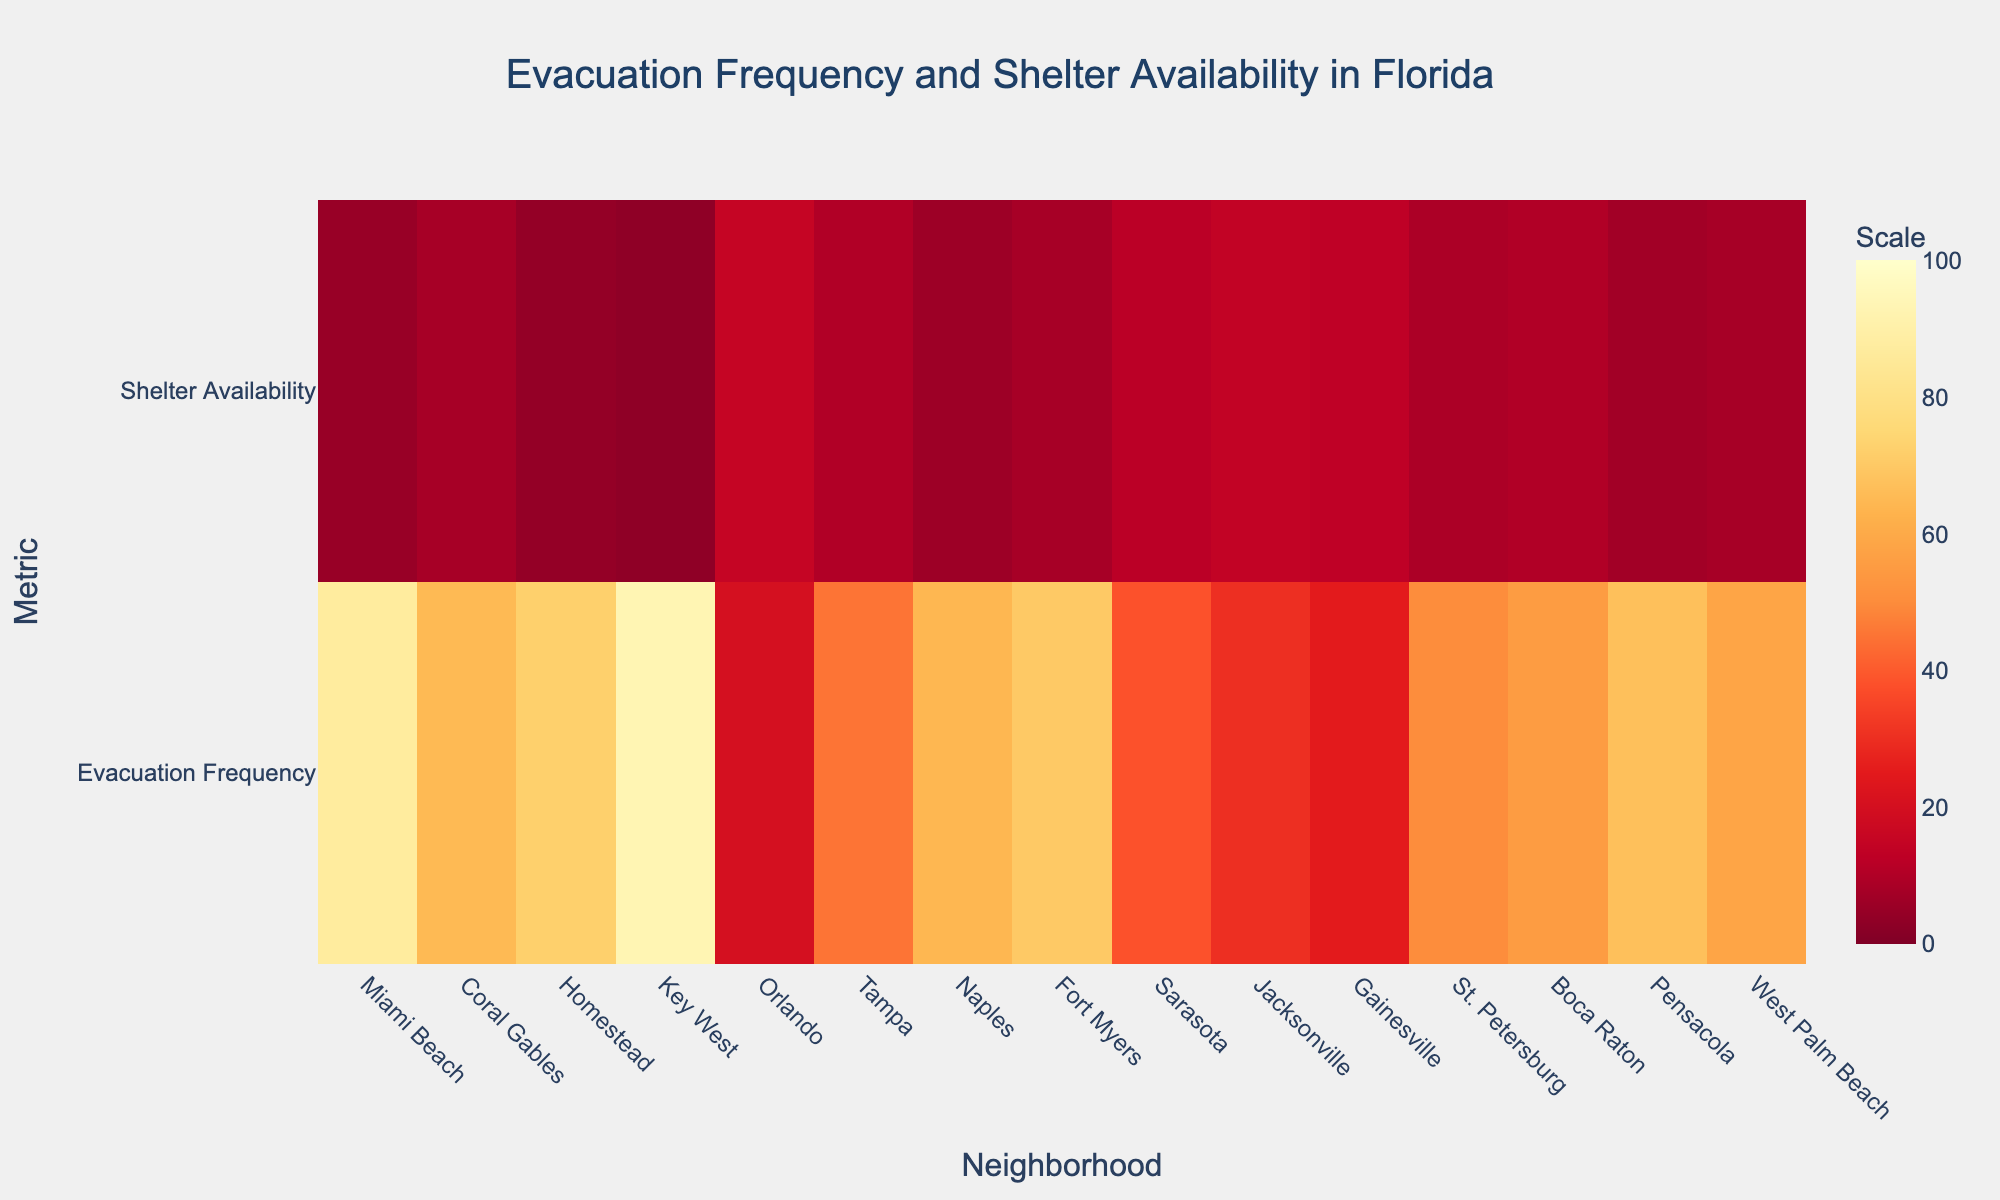What is the title of the heatmap? The title is prominently displayed at the top of the heatmap. It says, "Evacuation Frequency and Shelter Availability in Florida".
Answer: Evacuation Frequency and Shelter Availability in Florida How many neighborhoods are displayed in the heatmap? The heatmap axis labeled "Neighborhood" has tick marks corresponding to each neighborhood. Counting these ticks reveals the total number of neighborhoods.
Answer: 15 Which neighborhood has the highest evacuation frequency? On the heatmap, by comparing the "Evacuation Frequency" row's color intensity, the neighborhood with the most intense color (darkest) represents the highest frequency. This is located at "Key West".
Answer: Key West Which neighborhood has the highest shelter availability? Similarly, by looking at the "Shelter Availability" row's color intensity, the neighborhood with the most intense color represents the highest availability. This is located at "Orlando".
Answer: Orlando Which neighborhood has both high evacuation frequency and low shelter availability? A neighborhood with high evacuation frequency would appear dark in the "Evacuation Frequency" row, and the same neighborhood should appear lighter in the "Shelter Availability" row. "Key West" fits this description.
Answer: Key West Which neighborhood has both low evacuation frequency and high shelter availability? A neighborhood with low evacuation frequency will appear lighter in the "Evacuation Frequency" row, and that same neighborhood should appear darker in the "Shelter Availability" row, signifying high availability. "Orlando" fits this description.
Answer: Orlando What is the difference in evacuation frequency between Miami Beach and Tampa? By noting the color intensities and corresponding values, Miami Beach has an evacuation frequency of 87 and Tampa has 45. Subtracting these gives the difference: 87 - 45 = 42.
Answer: 42 Which neighborhoods have an evacuation frequency greater than 50 but a shelter availability of less than 10? By inspecting the heatmap, identify neighborhoods with darker shades in the "Evacuation Frequency" row and lighter shades in the "Shelter Availability" row. They are "Miami Beach", "Coral Gables", "Homestead", "Key West", "Naples", "Fort Myers", "Pensacola", and "West Palm Beach".
Answer: Miami Beach, Coral Gables, Homestead, Key West, Naples, Fort Myers, Pensacola, West Palm Beach What is the average shelter availability for neighborhoods with an evacuation frequency between 50 and 70? Identify neighborhoods fulfilling the evacuation frequency criterion: "Coral Gables", "Homestead", "Naples", "Fort Myers", "St. Petersburg", "Boca Raton", and "West Palm Beach". Their shelter availabilities are 8, 4, 6, 8, 9, 10, and 8 respectively. Calculating the average: (8 + 4 + 6 + 8 + 9 + 10 + 8) / 7 ≈ 7.6.
Answer: 7.6 Which two neighborhoods have the closest evacuation frequencies? By comparing numerical values, "Fort Myers" and "Homestead" both have closest frequencies of 70 and 72 respectively. The difference is 2, smaller than any other pair's difference.
Answer: Fort Myers and Homestead 